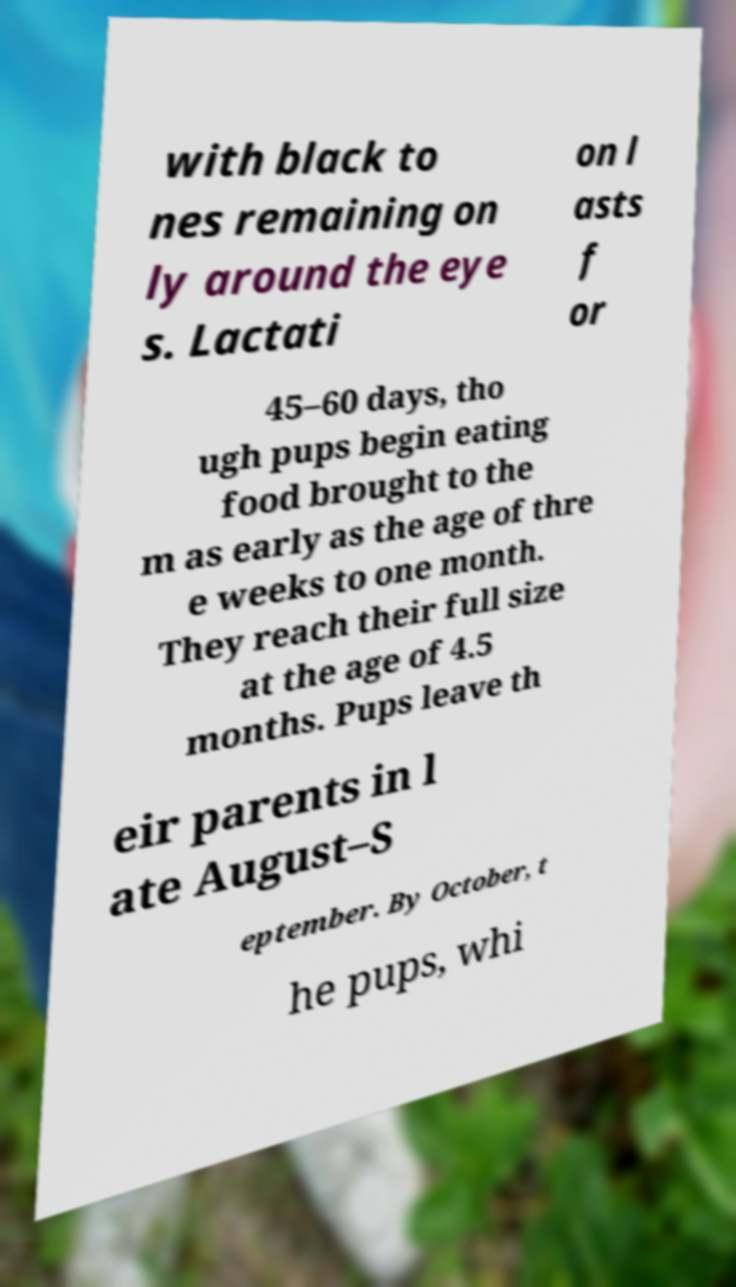There's text embedded in this image that I need extracted. Can you transcribe it verbatim? with black to nes remaining on ly around the eye s. Lactati on l asts f or 45–60 days, tho ugh pups begin eating food brought to the m as early as the age of thre e weeks to one month. They reach their full size at the age of 4.5 months. Pups leave th eir parents in l ate August–S eptember. By October, t he pups, whi 